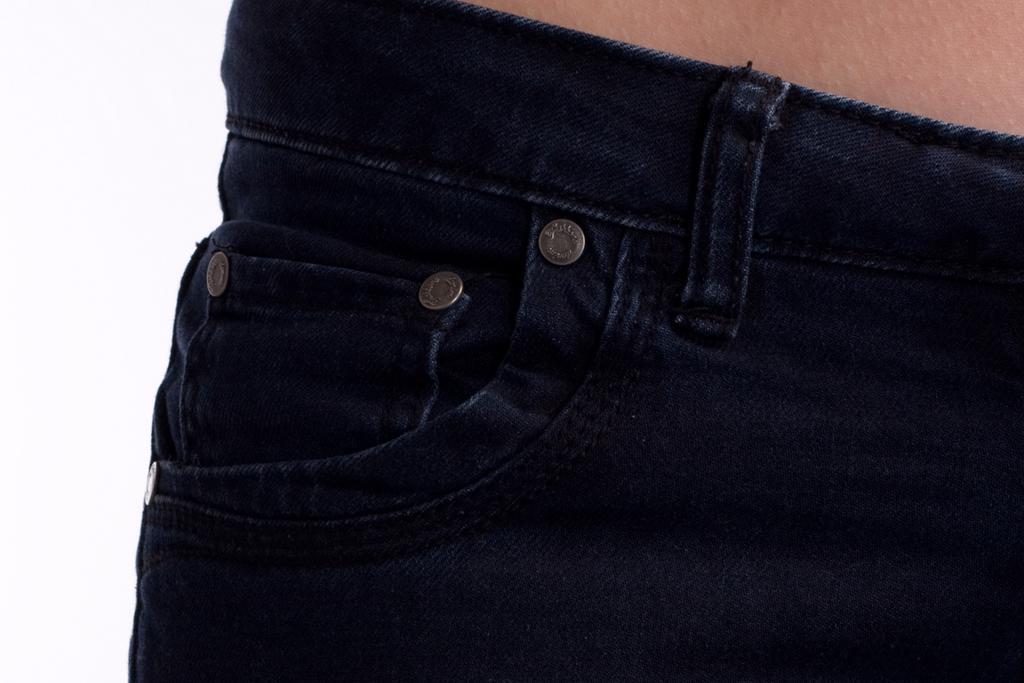Could you give a brief overview of what you see in this image? In the image in the center, we can see one dark blue jeans. 